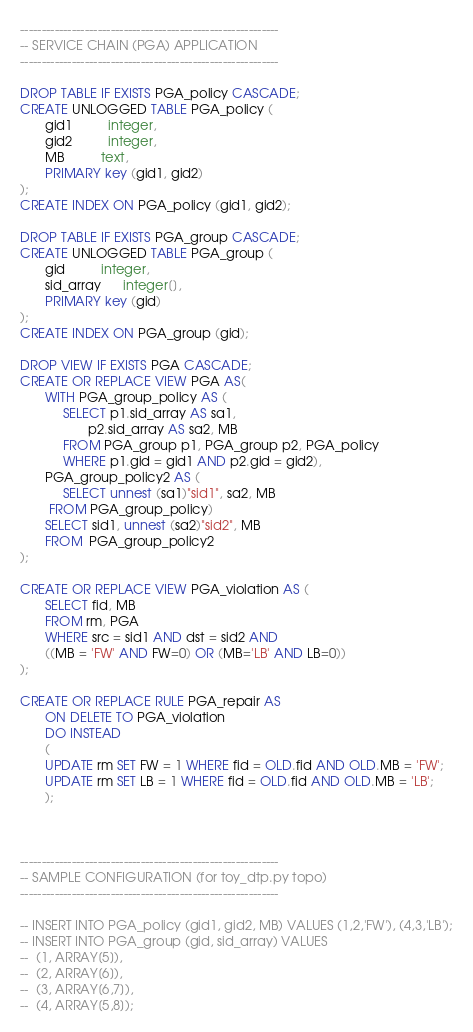Convert code to text. <code><loc_0><loc_0><loc_500><loc_500><_SQL_>------------------------------------------------------------
-- SERVICE CHAIN (PGA) APPLICATION
------------------------------------------------------------

DROP TABLE IF EXISTS PGA_policy CASCADE;
CREATE UNLOGGED TABLE PGA_policy (
       gid1	      integer,
       gid2 	      integer,
       MB	      text,
       PRIMARY key (gid1, gid2)
);
CREATE INDEX ON PGA_policy (gid1, gid2);

DROP TABLE IF EXISTS PGA_group CASCADE;
CREATE UNLOGGED TABLE PGA_group (
       gid	      integer,
       sid_array      integer[],
       PRIMARY key (gid)
);
CREATE INDEX ON PGA_group (gid);

DROP VIEW IF EXISTS PGA CASCADE;
CREATE OR REPLACE VIEW PGA AS(
       WITH PGA_group_policy AS (
       	    SELECT p1.sid_array AS sa1,
       	      	   p2.sid_array AS sa2, MB
            FROM PGA_group p1, PGA_group p2, PGA_policy
       	    WHERE p1.gid = gid1 AND p2.gid = gid2),
       PGA_group_policy2 AS (
            SELECT unnest (sa1)"sid1", sa2, MB
	    FROM PGA_group_policy)
       SELECT sid1, unnest (sa2)"sid2", MB
       FROM  PGA_group_policy2
);

CREATE OR REPLACE VIEW PGA_violation AS (
       SELECT fid, MB
       FROM rm, PGA
       WHERE src = sid1 AND dst = sid2 AND
       ((MB = 'FW' AND FW=0) OR (MB='LB' AND LB=0))
);

CREATE OR REPLACE RULE PGA_repair AS
       ON DELETE TO PGA_violation
       DO INSTEAD
       (
       UPDATE rm SET FW = 1 WHERE fid = OLD.fid AND OLD.MB = 'FW';
       UPDATE rm SET LB = 1 WHERE fid = OLD.fid AND OLD.MB = 'LB';
       );



------------------------------------------------------------
-- SAMPLE CONFIGURATION (for toy_dtp.py topo)
------------------------------------------------------------

-- INSERT INTO PGA_policy (gid1, gid2, MB) VALUES (1,2,'FW'), (4,3,'LB');
-- INSERT INTO PGA_group (gid, sid_array) VALUES
-- 	(1, ARRAY[5]),
-- 	(2, ARRAY[6]),
-- 	(3, ARRAY[6,7]),
-- 	(4, ARRAY[5,8]);
</code> 